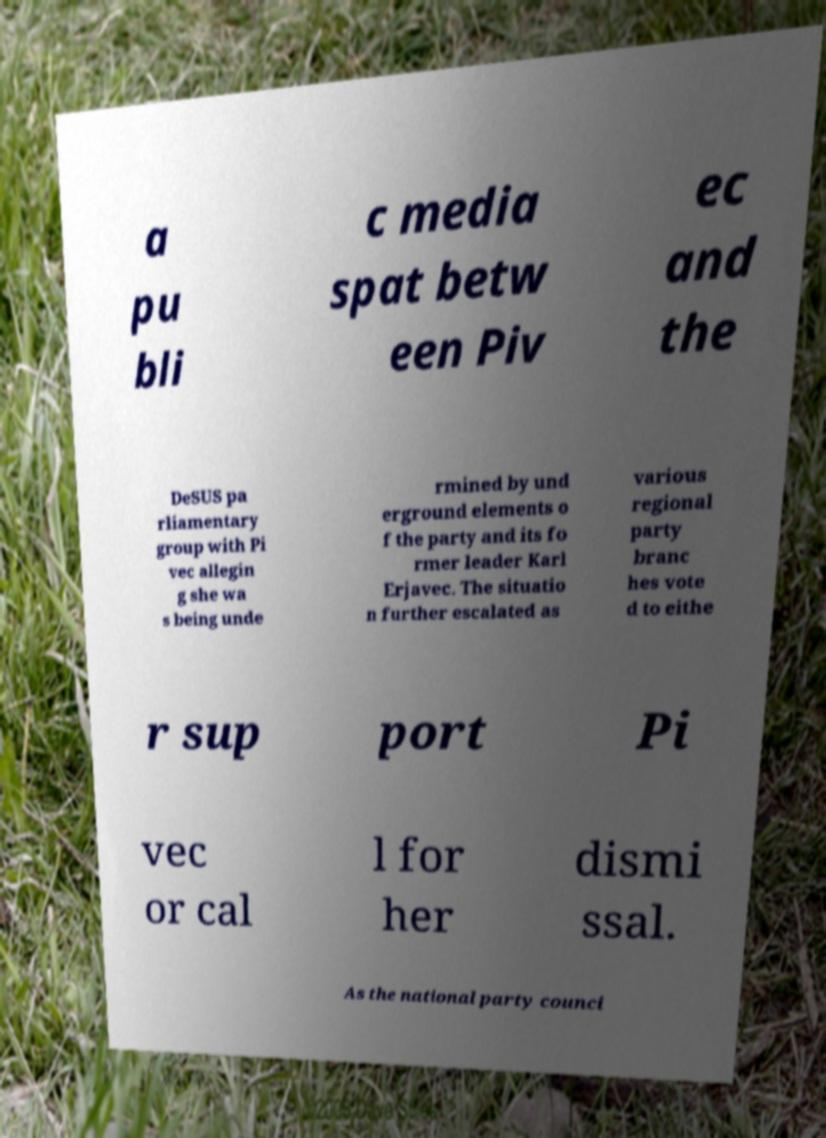There's text embedded in this image that I need extracted. Can you transcribe it verbatim? a pu bli c media spat betw een Piv ec and the DeSUS pa rliamentary group with Pi vec allegin g she wa s being unde rmined by und erground elements o f the party and its fo rmer leader Karl Erjavec. The situatio n further escalated as various regional party branc hes vote d to eithe r sup port Pi vec or cal l for her dismi ssal. As the national party counci 